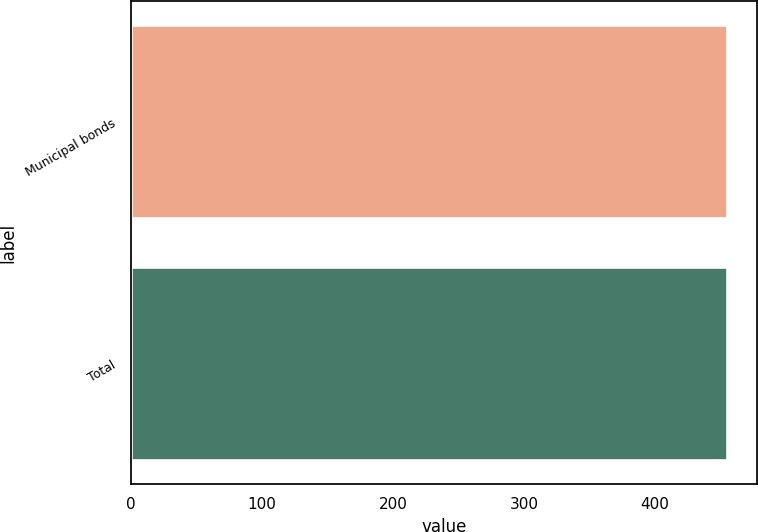Convert chart. <chart><loc_0><loc_0><loc_500><loc_500><bar_chart><fcel>Municipal bonds<fcel>Total<nl><fcel>455<fcel>455.1<nl></chart> 